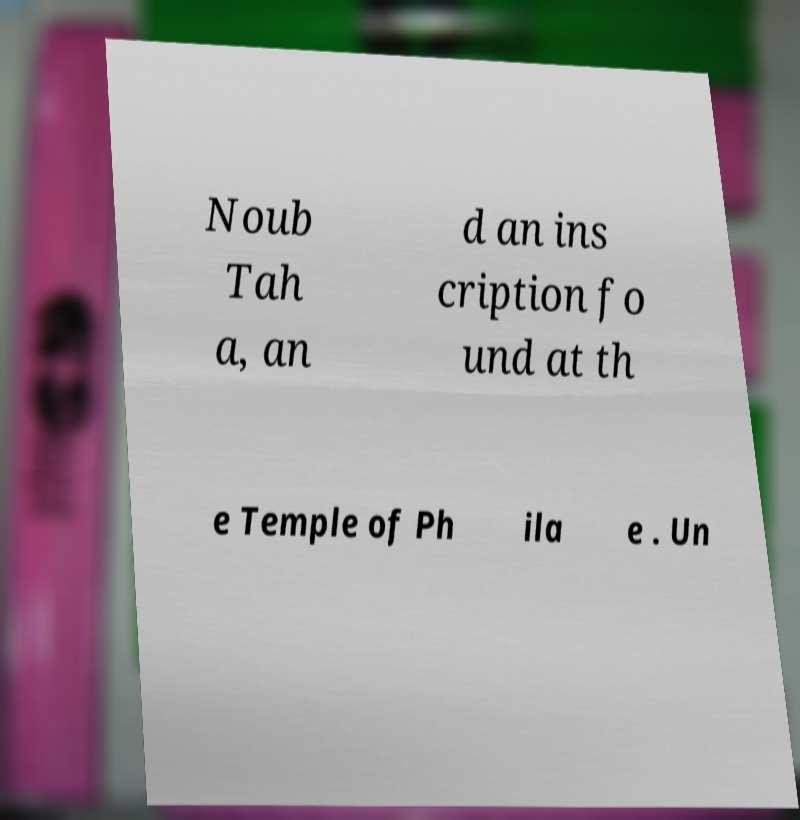Please read and relay the text visible in this image. What does it say? Noub Tah a, an d an ins cription fo und at th e Temple of Ph ila e . Un 